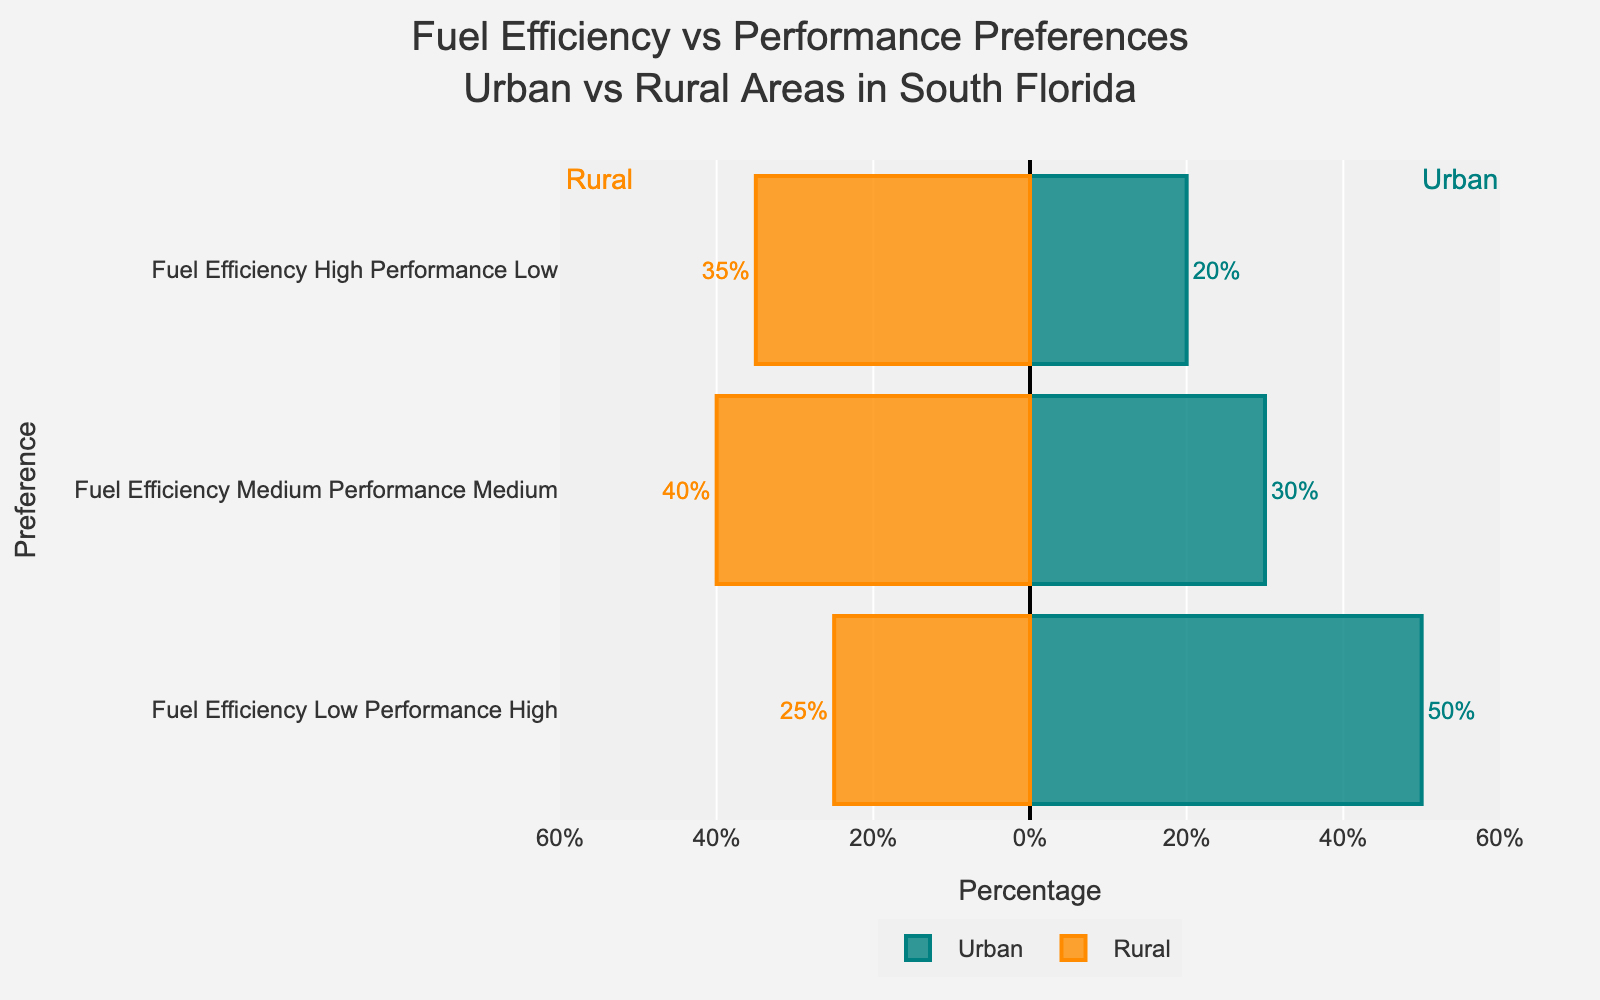What is the most preferred combination of Fuel Efficiency and Performance in urban areas? The urban area has bars showing preferences. The Fuel Efficiency Low Performance High bar is the longest, indicating it has the highest percentage.
Answer: Fuel Efficiency Low Performance High Which area has a higher percentage of people preferring high fuel efficiency and low performance? Comparing the bars for high fuel efficiency and low performance, the urban area has a bar at 20% and the rural area has a bar at 35%. 35% is higher than 20%.
Answer: Rural How many more people in rural areas prefer medium fuel efficiency and medium performance compared to those in urban areas? The rural bar for medium fuel efficiency and medium performance is at 40%, while the urban bar for the same preference is at 30%. The difference is 40% - 30%.
Answer: 10% What is the combined percentage of urban people preferring medium and low fuel efficiency options? Add the urban percentages for medium fuel efficiency (30%) and low fuel efficiency (50%). 30% + 50% = 80%.
Answer: 80% What is the difference in the percentage of urban and rural people preferring low fuel efficiency and high performance? The urban bar for low fuel efficiency and high performance is at 50%, and the rural bar is at 25%. The difference is 50% - 25%.
Answer: 25% Which area shows a greater overall preference for high fuel efficiency options? Sum the percentages for high fuel efficiency in both urban (20%) and rural (35%) areas. 35% is greater than 20%.
Answer: Rural In rural areas, what is the combined percentage of people who prefer low and medium fuel efficiency? Add the percentages for low fuel efficiency (25%) and medium fuel efficiency (40%). 25% + 40% = 65%.
Answer: 65% Which preference has the lowest percentage in rural areas? The rural area bars show low fuel efficiency and high performance at 25%, which is the smallest bar length.
Answer: Low Fuel Efficiency High Performance How does the percentage of urban people preferring medium fuel efficiency compare to that of rural people with the same preference? The medium fuel efficiency bar for urban areas is at 30%, while for rural areas it is at 40%. 30% is less than 40%.
Answer: Urban is less than Rural 